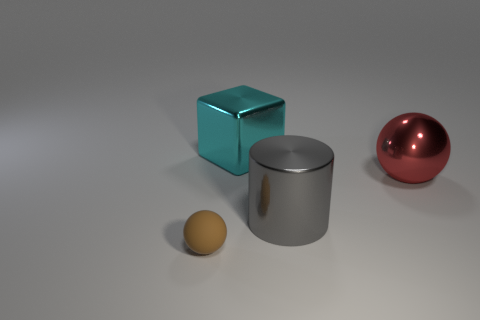Is there any other thing that has the same material as the tiny brown object?
Offer a very short reply. No. What shape is the large red object that is made of the same material as the cyan block?
Provide a short and direct response. Sphere. Is the number of cyan metal blocks behind the big red ball greater than the number of large shiny cylinders behind the large cylinder?
Your answer should be very brief. Yes. What number of things are either small brown cylinders or large red things?
Provide a succinct answer. 1. How many other objects are the same color as the small ball?
Offer a very short reply. 0. There is a gray object that is the same size as the cube; what shape is it?
Ensure brevity in your answer.  Cylinder. What is the color of the object that is left of the large metal cube?
Your answer should be compact. Brown. What number of objects are metal objects on the left side of the shiny ball or spheres to the right of the large metallic cylinder?
Provide a short and direct response. 3. Do the brown rubber sphere and the metallic block have the same size?
Provide a short and direct response. No. What number of spheres are small things or large gray shiny things?
Ensure brevity in your answer.  1. 